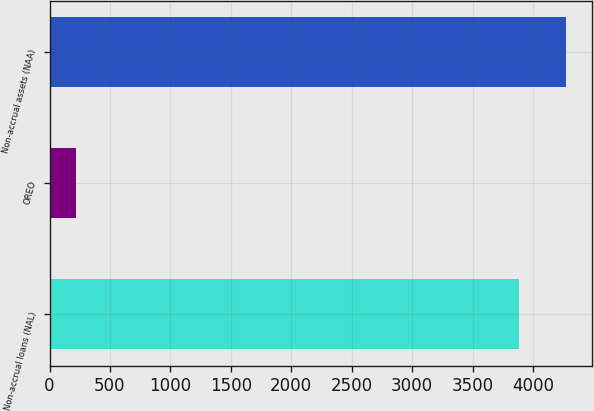Convert chart. <chart><loc_0><loc_0><loc_500><loc_500><bar_chart><fcel>Non-accrual loans (NAL)<fcel>OREO<fcel>Non-accrual assets (NAA)<nl><fcel>3888<fcel>219<fcel>4276.8<nl></chart> 